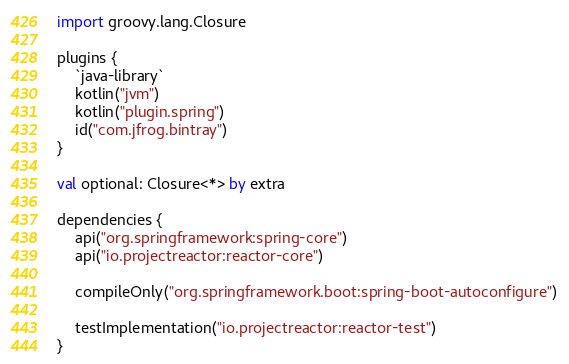Convert code to text. <code><loc_0><loc_0><loc_500><loc_500><_Kotlin_>import groovy.lang.Closure

plugins {
    `java-library`
    kotlin("jvm")
    kotlin("plugin.spring")
    id("com.jfrog.bintray")
}

val optional: Closure<*> by extra

dependencies {
    api("org.springframework:spring-core")
    api("io.projectreactor:reactor-core")

    compileOnly("org.springframework.boot:spring-boot-autoconfigure")

    testImplementation("io.projectreactor:reactor-test")
}
</code> 